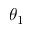Convert formula to latex. <formula><loc_0><loc_0><loc_500><loc_500>\theta _ { 1 }</formula> 